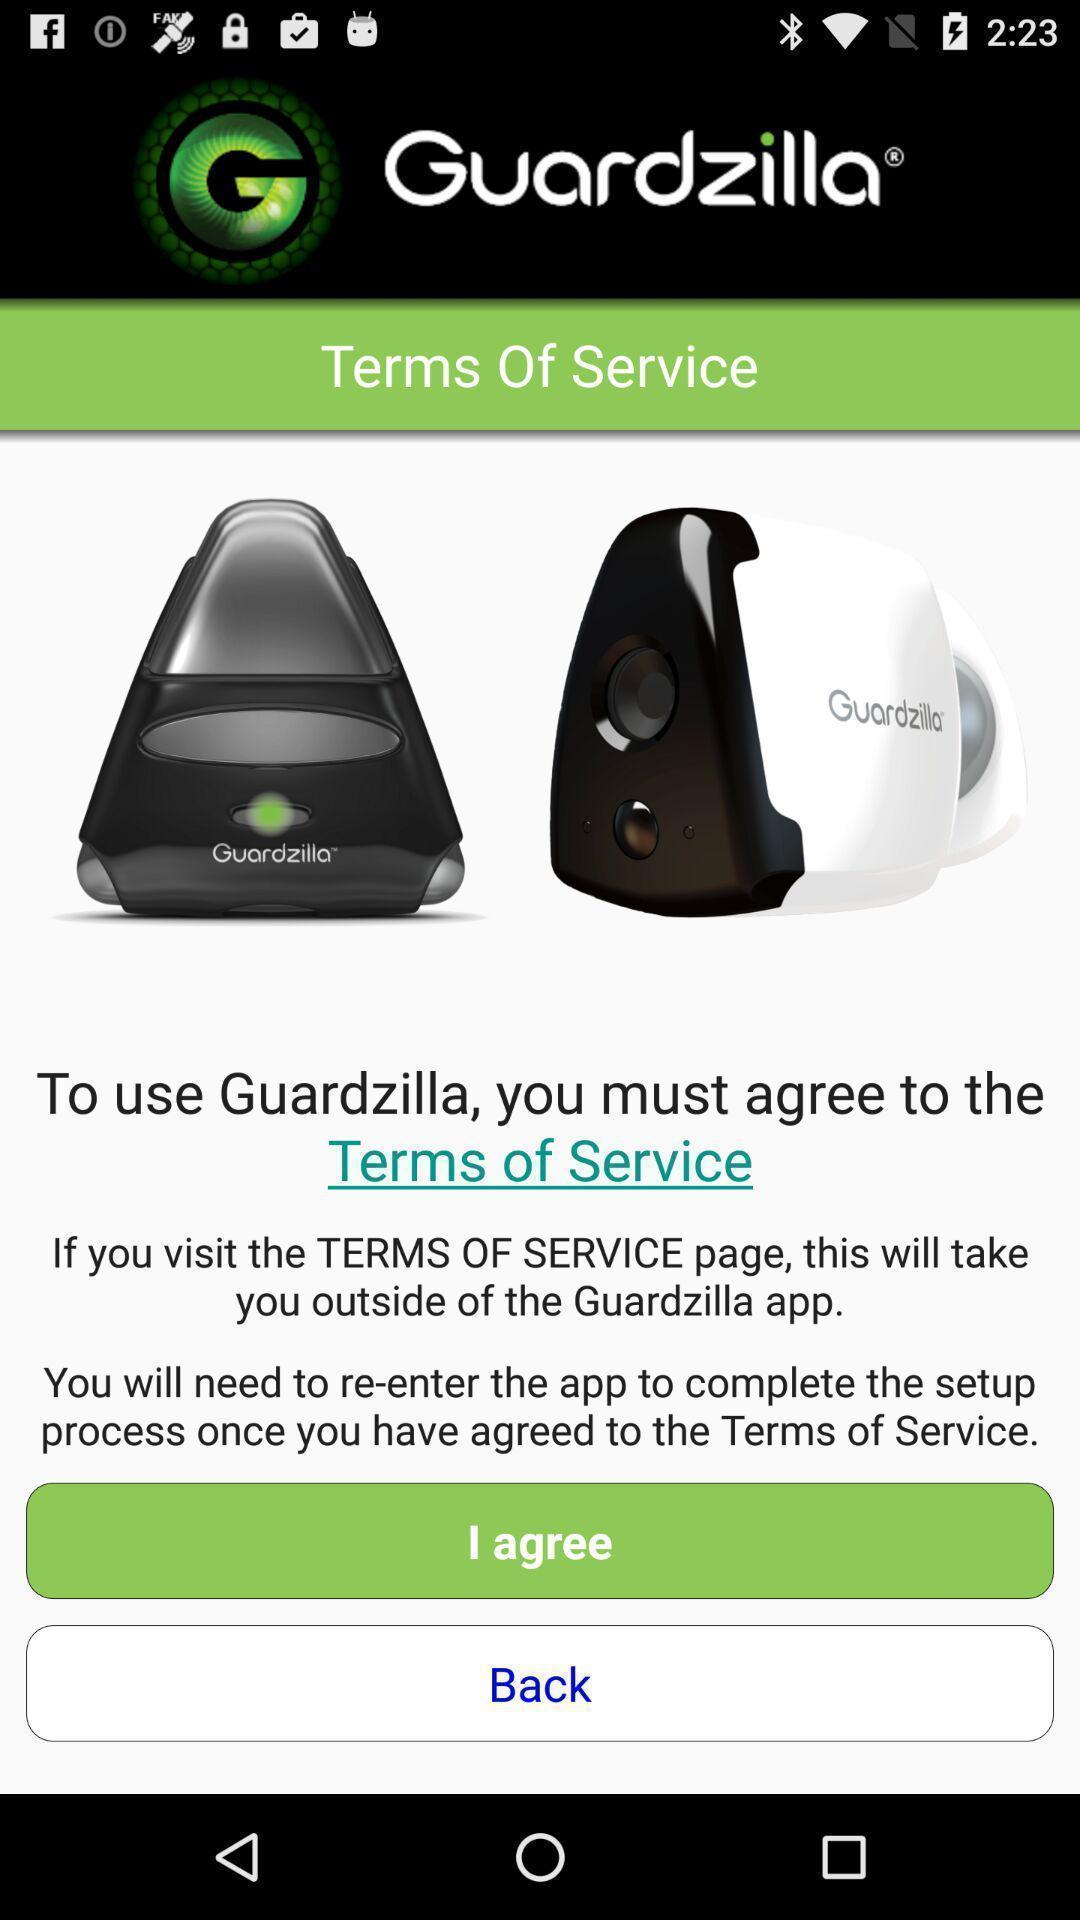Give me a summary of this screen capture. Terms of service page of a product. 